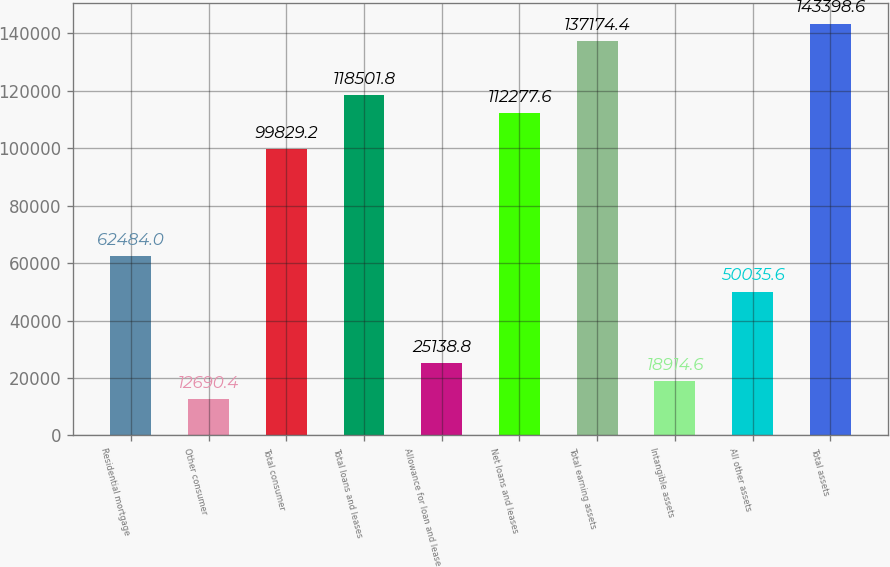Convert chart. <chart><loc_0><loc_0><loc_500><loc_500><bar_chart><fcel>Residential mortgage<fcel>Other consumer<fcel>Total consumer<fcel>Total loans and leases<fcel>Allowance for loan and lease<fcel>Net loans and leases<fcel>Total earning assets<fcel>Intangible assets<fcel>All other assets<fcel>Total assets<nl><fcel>62484<fcel>12690.4<fcel>99829.2<fcel>118502<fcel>25138.8<fcel>112278<fcel>137174<fcel>18914.6<fcel>50035.6<fcel>143399<nl></chart> 